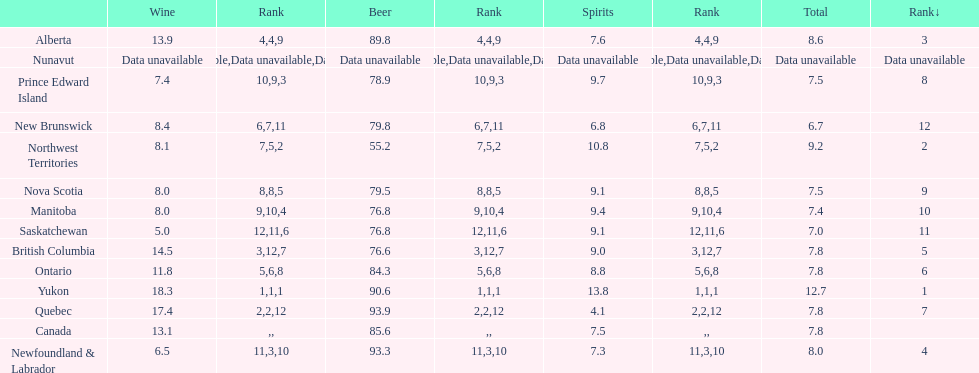Quebuec had a beer consumption of 93.9, what was their spirit consumption? 4.1. 